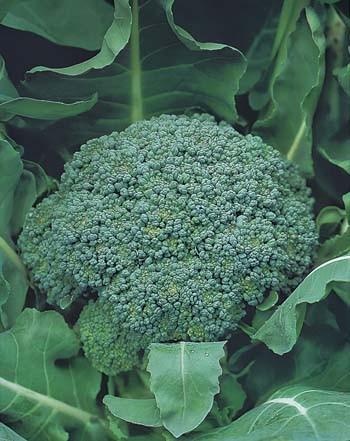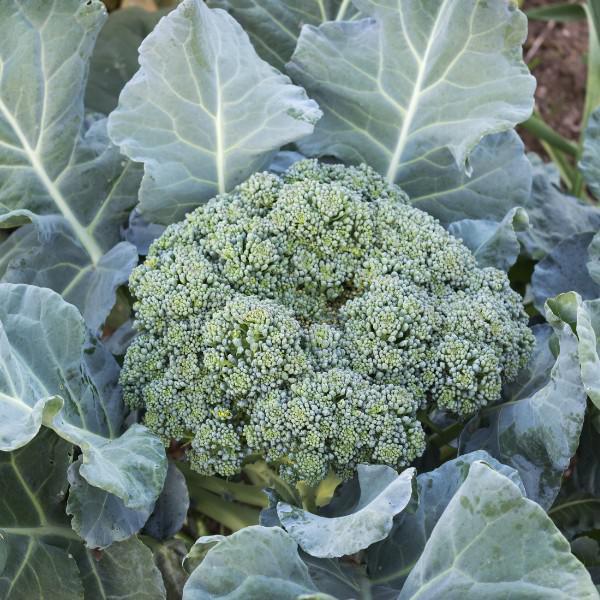The first image is the image on the left, the second image is the image on the right. For the images displayed, is the sentence "The left and right image contains the same number broccoli heads growing straight up." factually correct? Answer yes or no. Yes. 